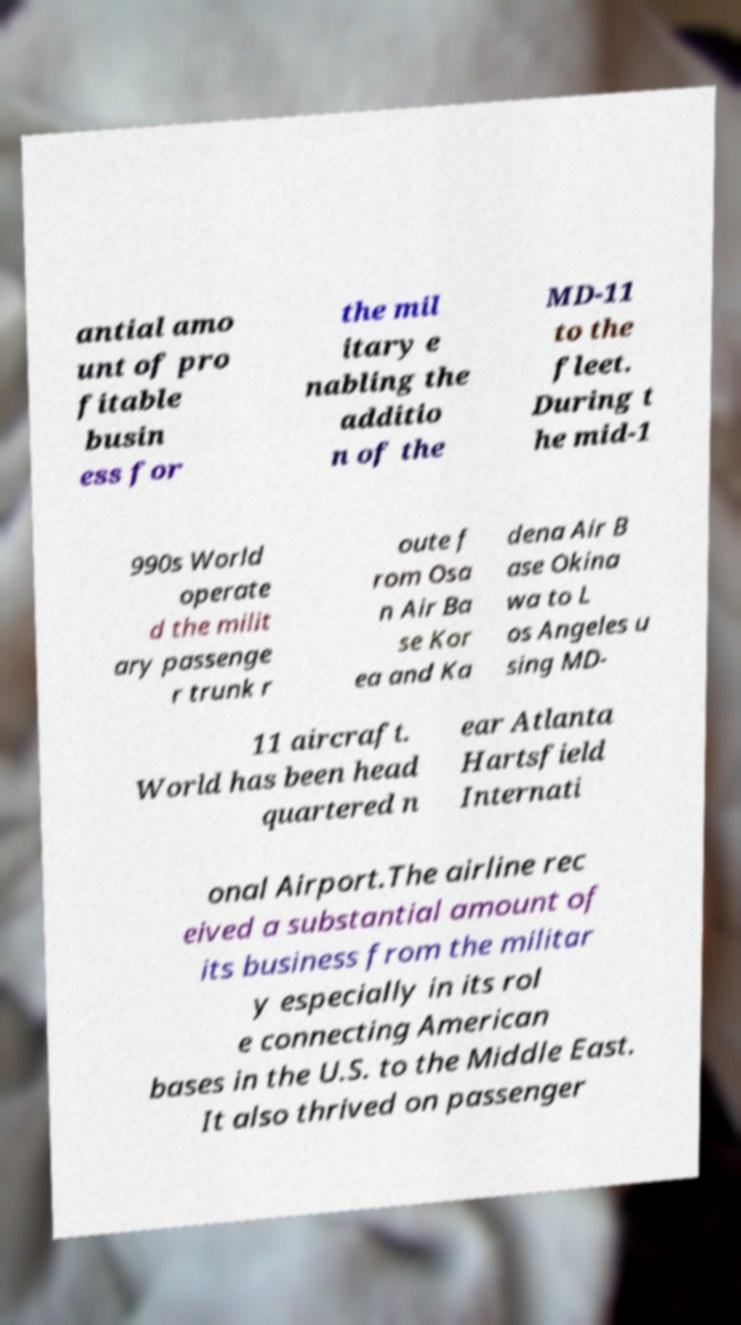Please read and relay the text visible in this image. What does it say? antial amo unt of pro fitable busin ess for the mil itary e nabling the additio n of the MD-11 to the fleet. During t he mid-1 990s World operate d the milit ary passenge r trunk r oute f rom Osa n Air Ba se Kor ea and Ka dena Air B ase Okina wa to L os Angeles u sing MD- 11 aircraft. World has been head quartered n ear Atlanta Hartsfield Internati onal Airport.The airline rec eived a substantial amount of its business from the militar y especially in its rol e connecting American bases in the U.S. to the Middle East. It also thrived on passenger 